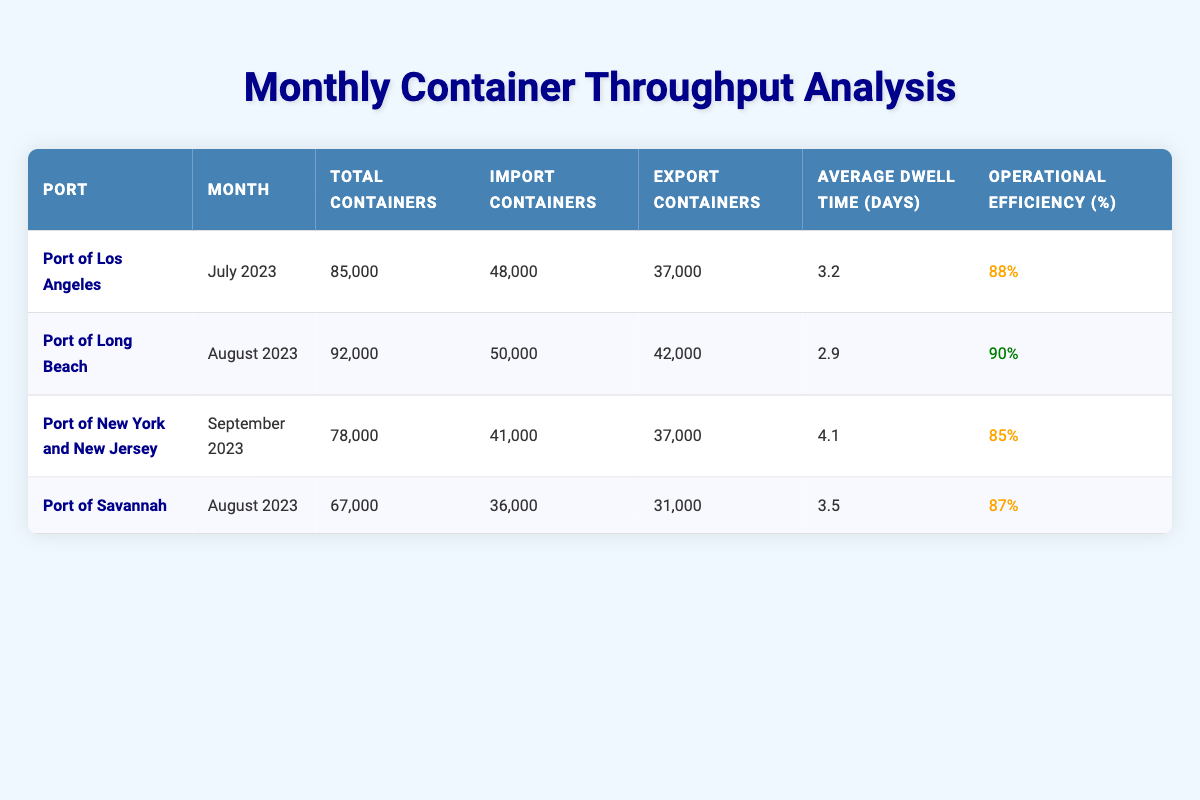What is the total number of containers handled at the Port of Los Angeles in July 2023? The total containers for the Port of Los Angeles in July 2023 can be directly found in the table under the "Total Containers" column, which shows 85,000.
Answer: 85,000 Which port had the highest operational efficiency in the last quarter? By comparing the "Operational Efficiency (%)" values for each port, the Port of Long Beach has the highest operational efficiency at 90%.
Answer: Port of Long Beach What is the average dwell time for containers at the Port of New York and New Jersey? The average dwell time for the Port of New York and New Jersey can be found in the respective row under the "Average Dwell Time (days)" column, which indicates it is 4.1 days.
Answer: 4.1 days How many more import containers were handled at the Port of Long Beach compared to the Port of Savannah in August 2023? To find the difference in import containers, we need to subtract the number of import containers at the Port of Savannah (36,000) from those at the Port of Long Beach (50,000). The calculation is 50,000 - 36,000 = 14,000.
Answer: 14,000 Is the average dwell time of containers at the Port of Los Angeles higher than that at the Port of Savannah? The average dwell time for the Port of Los Angeles is 3.2 days, while for the Port of Savannah, it is 3.5 days. Since 3.2 is less than 3.5, the statement is false.
Answer: No What is the total number of export containers for both the Port of Los Angeles and the Port of Savannah combined? To find the combined total of export containers, we add the export containers from the Port of Los Angeles (37,000) and the Port of Savannah (31,000). The total is 37,000 + 31,000 = 68,000.
Answer: 68,000 Which port had the lowest total container throughput, and what was the amount? By comparing the "Total Containers" column for all the ports, the Port of New York and New Jersey has the lowest total with 78,000 containers.
Answer: Port of New York and New Jersey, 78,000 What is the difference in total containers handled between the Port of Los Angeles and the Port of Long Beach? The total containers for the Port of Los Angeles is 85,000 and for the Port of Long Beach is 92,000. The difference is calculated as 92,000 - 85,000 = 7,000.
Answer: 7,000 Was the operational efficiency of the Port of Savannah lower than that of the Port of New York and New Jersey? The operational efficiency at the Port of Savannah is 87% while at the Port of New York and New Jersey it is 85%. Since 87% is greater than 85%, the statement is false.
Answer: No 